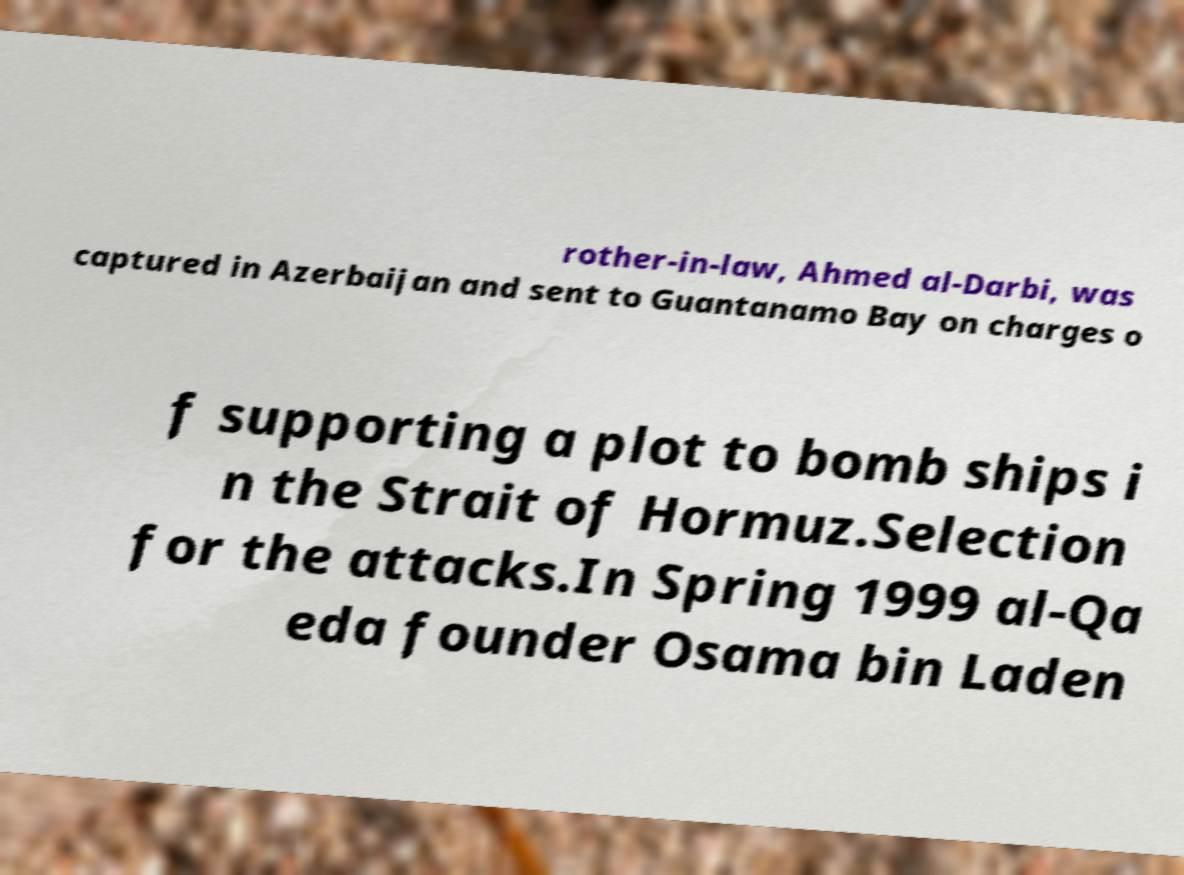What messages or text are displayed in this image? I need them in a readable, typed format. rother-in-law, Ahmed al-Darbi, was captured in Azerbaijan and sent to Guantanamo Bay on charges o f supporting a plot to bomb ships i n the Strait of Hormuz.Selection for the attacks.In Spring 1999 al-Qa eda founder Osama bin Laden 